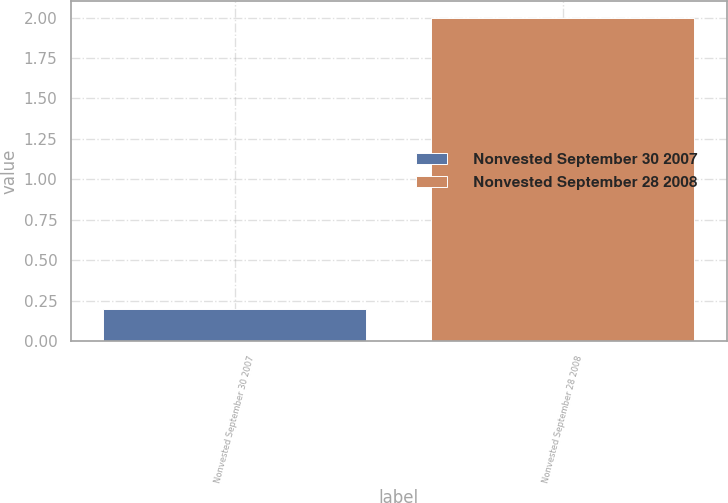Convert chart. <chart><loc_0><loc_0><loc_500><loc_500><bar_chart><fcel>Nonvested September 30 2007<fcel>Nonvested September 28 2008<nl><fcel>0.2<fcel>2<nl></chart> 